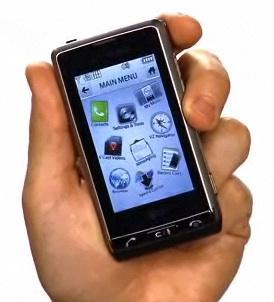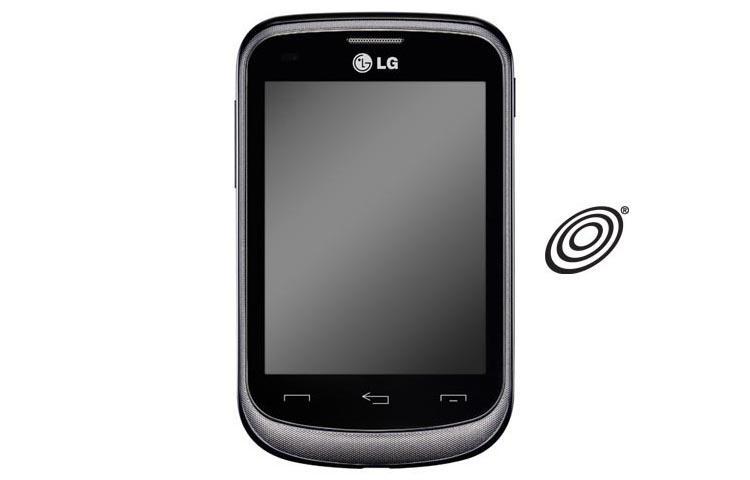The first image is the image on the left, the second image is the image on the right. Analyze the images presented: Is the assertion "Only one hand is visible." valid? Answer yes or no. Yes. The first image is the image on the left, the second image is the image on the right. Examine the images to the left and right. Is the description "One image shows a rectangular gray phone with a gray screen, and the other image shows a hand holding a phone." accurate? Answer yes or no. Yes. 